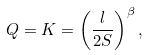Convert formula to latex. <formula><loc_0><loc_0><loc_500><loc_500>Q = K = \left ( \frac { l } { 2 S } \right ) ^ { \beta } ,</formula> 